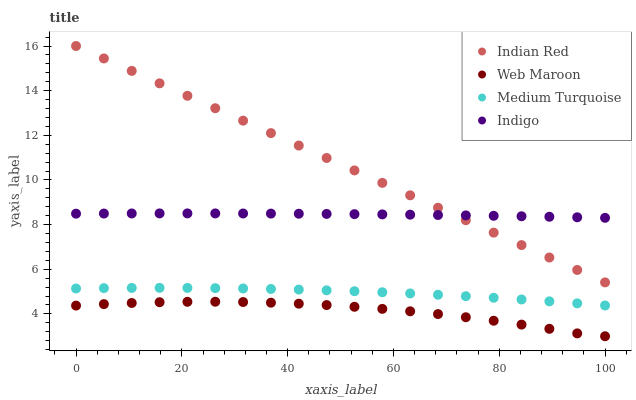Does Web Maroon have the minimum area under the curve?
Answer yes or no. Yes. Does Indian Red have the maximum area under the curve?
Answer yes or no. Yes. Does Medium Turquoise have the minimum area under the curve?
Answer yes or no. No. Does Medium Turquoise have the maximum area under the curve?
Answer yes or no. No. Is Indian Red the smoothest?
Answer yes or no. Yes. Is Web Maroon the roughest?
Answer yes or no. Yes. Is Medium Turquoise the smoothest?
Answer yes or no. No. Is Medium Turquoise the roughest?
Answer yes or no. No. Does Web Maroon have the lowest value?
Answer yes or no. Yes. Does Medium Turquoise have the lowest value?
Answer yes or no. No. Does Indian Red have the highest value?
Answer yes or no. Yes. Does Medium Turquoise have the highest value?
Answer yes or no. No. Is Medium Turquoise less than Indian Red?
Answer yes or no. Yes. Is Indigo greater than Medium Turquoise?
Answer yes or no. Yes. Does Indian Red intersect Indigo?
Answer yes or no. Yes. Is Indian Red less than Indigo?
Answer yes or no. No. Is Indian Red greater than Indigo?
Answer yes or no. No. Does Medium Turquoise intersect Indian Red?
Answer yes or no. No. 